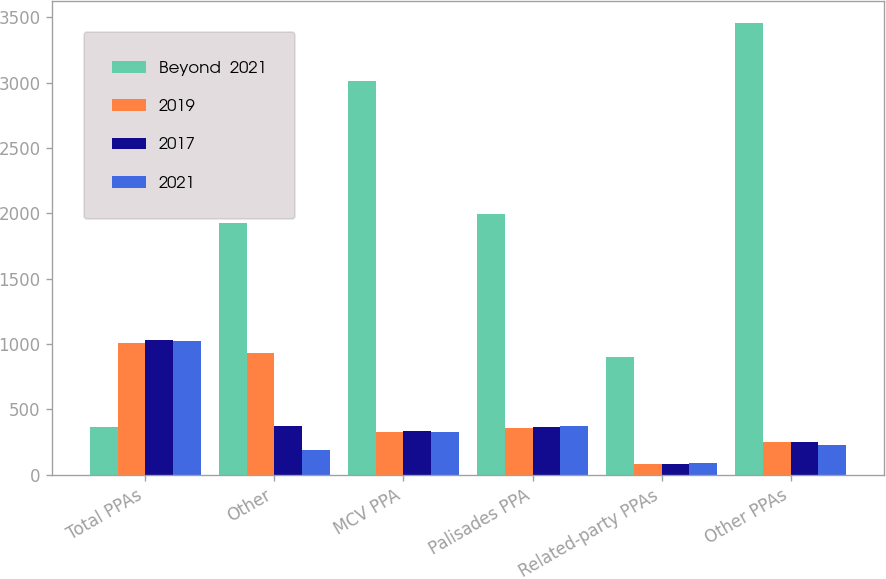Convert chart to OTSL. <chart><loc_0><loc_0><loc_500><loc_500><stacked_bar_chart><ecel><fcel>Total PPAs<fcel>Other<fcel>MCV PPA<fcel>Palisades PPA<fcel>Related-party PPAs<fcel>Other PPAs<nl><fcel>Beyond  2021<fcel>365<fcel>1922<fcel>3010<fcel>1994<fcel>899<fcel>3453<nl><fcel>2019<fcel>1008<fcel>931<fcel>326<fcel>354<fcel>81<fcel>247<nl><fcel>2017<fcel>1031<fcel>376<fcel>331<fcel>365<fcel>82<fcel>253<nl><fcel>2021<fcel>1021<fcel>187<fcel>330<fcel>376<fcel>86<fcel>229<nl></chart> 